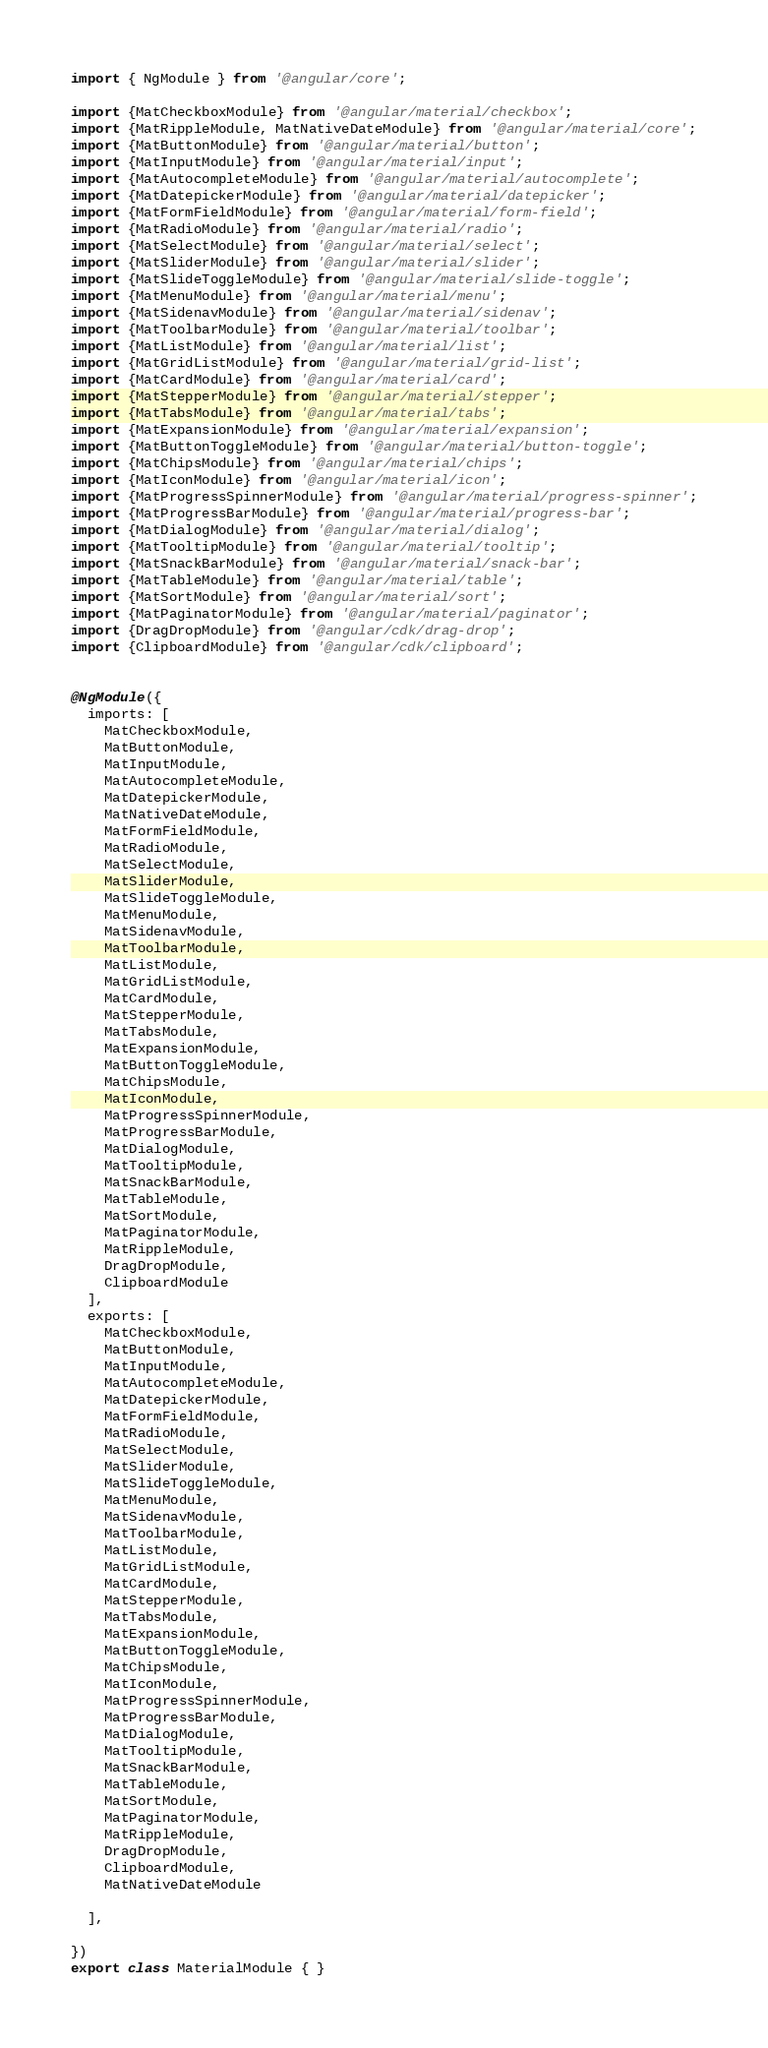<code> <loc_0><loc_0><loc_500><loc_500><_TypeScript_>import { NgModule } from '@angular/core';

import {MatCheckboxModule} from '@angular/material/checkbox';
import {MatRippleModule, MatNativeDateModule} from '@angular/material/core';
import {MatButtonModule} from '@angular/material/button';
import {MatInputModule} from '@angular/material/input';
import {MatAutocompleteModule} from '@angular/material/autocomplete';
import {MatDatepickerModule} from '@angular/material/datepicker';
import {MatFormFieldModule} from '@angular/material/form-field';
import {MatRadioModule} from '@angular/material/radio';
import {MatSelectModule} from '@angular/material/select';
import {MatSliderModule} from '@angular/material/slider';
import {MatSlideToggleModule} from '@angular/material/slide-toggle';
import {MatMenuModule} from '@angular/material/menu';
import {MatSidenavModule} from '@angular/material/sidenav';
import {MatToolbarModule} from '@angular/material/toolbar';
import {MatListModule} from '@angular/material/list';
import {MatGridListModule} from '@angular/material/grid-list';
import {MatCardModule} from '@angular/material/card';
import {MatStepperModule} from '@angular/material/stepper';
import {MatTabsModule} from '@angular/material/tabs';
import {MatExpansionModule} from '@angular/material/expansion';
import {MatButtonToggleModule} from '@angular/material/button-toggle';
import {MatChipsModule} from '@angular/material/chips';
import {MatIconModule} from '@angular/material/icon';
import {MatProgressSpinnerModule} from '@angular/material/progress-spinner';
import {MatProgressBarModule} from '@angular/material/progress-bar';
import {MatDialogModule} from '@angular/material/dialog';
import {MatTooltipModule} from '@angular/material/tooltip';
import {MatSnackBarModule} from '@angular/material/snack-bar';
import {MatTableModule} from '@angular/material/table';
import {MatSortModule} from '@angular/material/sort';
import {MatPaginatorModule} from '@angular/material/paginator';
import {DragDropModule} from '@angular/cdk/drag-drop';
import {ClipboardModule} from '@angular/cdk/clipboard';


@NgModule({
  imports: [
    MatCheckboxModule,
    MatButtonModule,
    MatInputModule,
    MatAutocompleteModule,
    MatDatepickerModule,
    MatNativeDateModule,
    MatFormFieldModule,
    MatRadioModule,
    MatSelectModule,
    MatSliderModule,
    MatSlideToggleModule,
    MatMenuModule,
    MatSidenavModule,
    MatToolbarModule,
    MatListModule,
    MatGridListModule,
    MatCardModule,
    MatStepperModule,
    MatTabsModule,
    MatExpansionModule,
    MatButtonToggleModule,
    MatChipsModule,
    MatIconModule,
    MatProgressSpinnerModule,
    MatProgressBarModule,
    MatDialogModule,
    MatTooltipModule,
    MatSnackBarModule,
    MatTableModule,
    MatSortModule,
    MatPaginatorModule,
    MatRippleModule,
    DragDropModule,
    ClipboardModule
  ],
  exports: [
    MatCheckboxModule,
    MatButtonModule,
    MatInputModule,
    MatAutocompleteModule,
    MatDatepickerModule,
    MatFormFieldModule,
    MatRadioModule,
    MatSelectModule,
    MatSliderModule,
    MatSlideToggleModule,
    MatMenuModule,
    MatSidenavModule,
    MatToolbarModule,
    MatListModule,
    MatGridListModule,
    MatCardModule,
    MatStepperModule,
    MatTabsModule,
    MatExpansionModule,
    MatButtonToggleModule,
    MatChipsModule,
    MatIconModule,
    MatProgressSpinnerModule,
    MatProgressBarModule,
    MatDialogModule,
    MatTooltipModule,
    MatSnackBarModule,
    MatTableModule,
    MatSortModule,
    MatPaginatorModule,
    MatRippleModule,
    DragDropModule,
    ClipboardModule,
    MatNativeDateModule

  ],

})
export class MaterialModule { }
</code> 